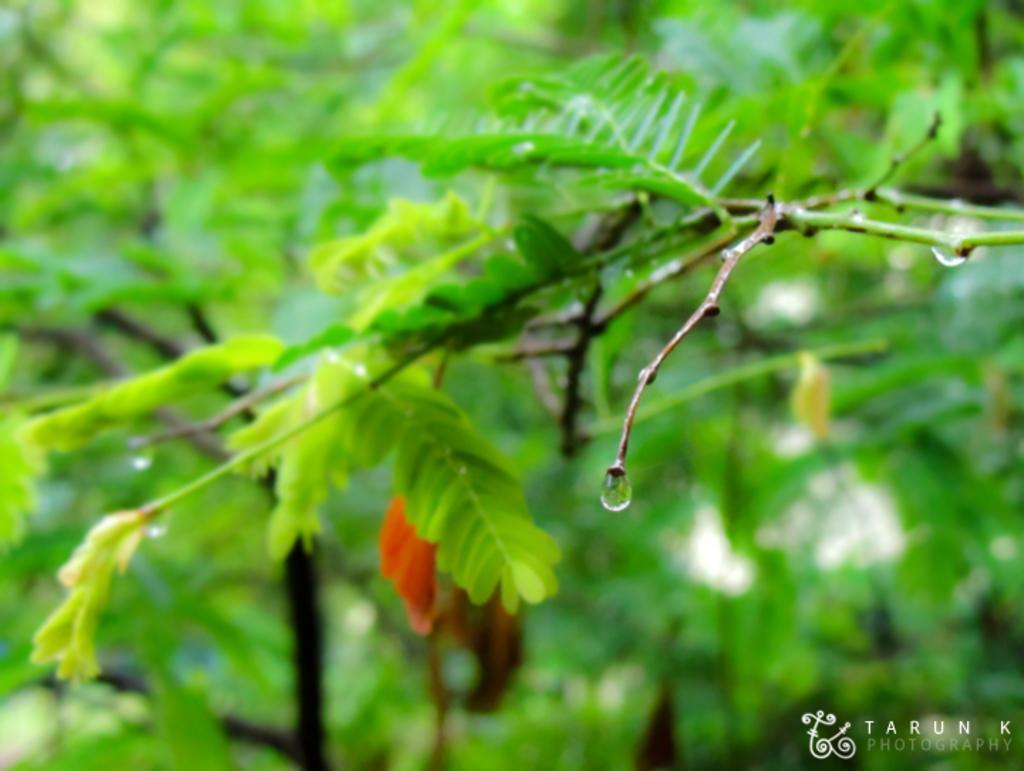Can you describe this image briefly? In this picture we can see some leaves and water drops to the stem. 